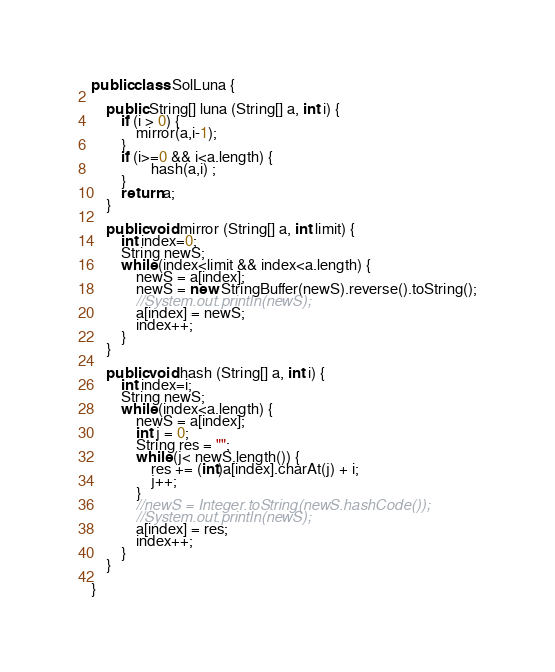<code> <loc_0><loc_0><loc_500><loc_500><_Java_>public class SolLuna {

    public String[] luna (String[] a, int i) {
        if (i > 0) {
            mirror(a,i-1);
        }
        if (i>=0 && i<a.length) {
                hash(a,i) ;
        }
        return a;
    }

    public void mirror (String[] a, int limit) {
        int index=0;
        String newS;
        while (index<limit && index<a.length) {
            newS = a[index];
            newS = new StringBuffer(newS).reverse().toString();
            //System.out.println(newS);
            a[index] = newS;
            index++;
        }
    }

    public void hash (String[] a, int i) {
        int index=i;
        String newS;
        while (index<a.length) {
            newS = a[index];
            int j = 0;
            String res = "";
            while (j< newS.length()) {
                res += (int)a[index].charAt(j) + i;
                j++;
            }
            //newS = Integer.toString(newS.hashCode());
            //System.out.println(newS);
            a[index] = res;
            index++;
        }
    }

}</code> 